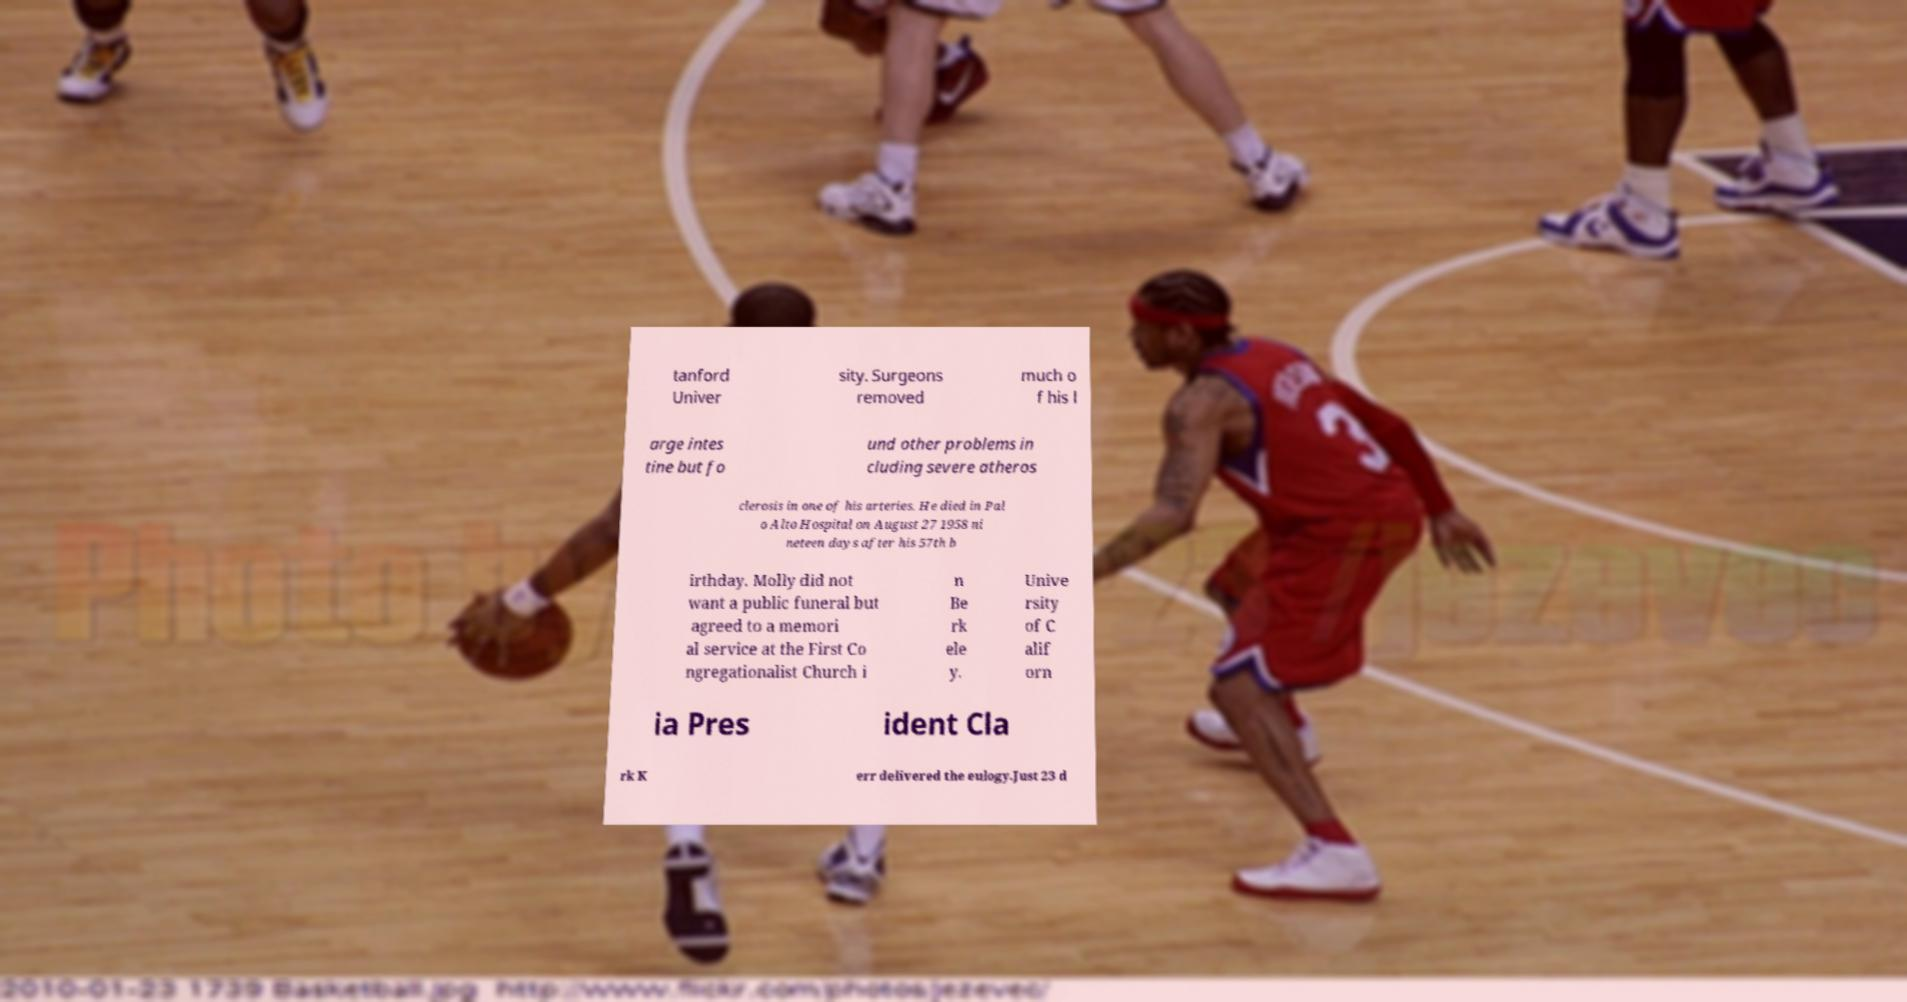What messages or text are displayed in this image? I need them in a readable, typed format. tanford Univer sity. Surgeons removed much o f his l arge intes tine but fo und other problems in cluding severe atheros clerosis in one of his arteries. He died in Pal o Alto Hospital on August 27 1958 ni neteen days after his 57th b irthday. Molly did not want a public funeral but agreed to a memori al service at the First Co ngregationalist Church i n Be rk ele y. Unive rsity of C alif orn ia Pres ident Cla rk K err delivered the eulogy.Just 23 d 